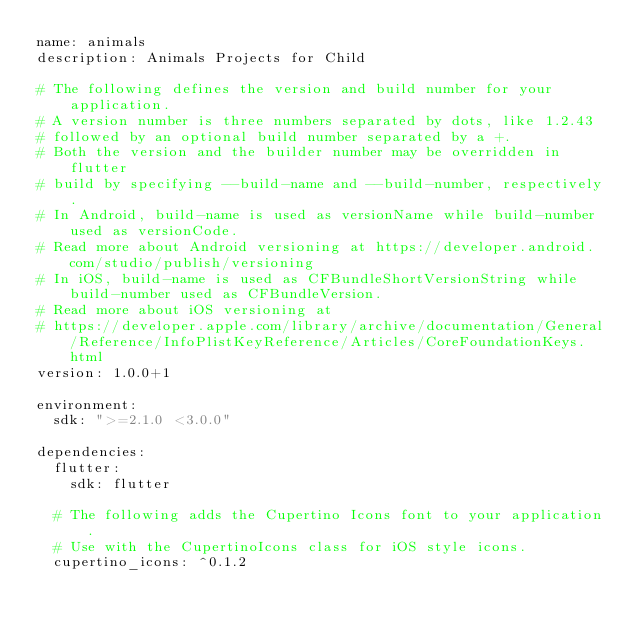Convert code to text. <code><loc_0><loc_0><loc_500><loc_500><_YAML_>name: animals
description: Animals Projects for Child 

# The following defines the version and build number for your application.
# A version number is three numbers separated by dots, like 1.2.43
# followed by an optional build number separated by a +.
# Both the version and the builder number may be overridden in flutter
# build by specifying --build-name and --build-number, respectively.
# In Android, build-name is used as versionName while build-number used as versionCode.
# Read more about Android versioning at https://developer.android.com/studio/publish/versioning
# In iOS, build-name is used as CFBundleShortVersionString while build-number used as CFBundleVersion.
# Read more about iOS versioning at
# https://developer.apple.com/library/archive/documentation/General/Reference/InfoPlistKeyReference/Articles/CoreFoundationKeys.html
version: 1.0.0+1

environment:
  sdk: ">=2.1.0 <3.0.0"

dependencies:
  flutter:
    sdk: flutter

  # The following adds the Cupertino Icons font to your application.
  # Use with the CupertinoIcons class for iOS style icons.
  cupertino_icons: ^0.1.2</code> 